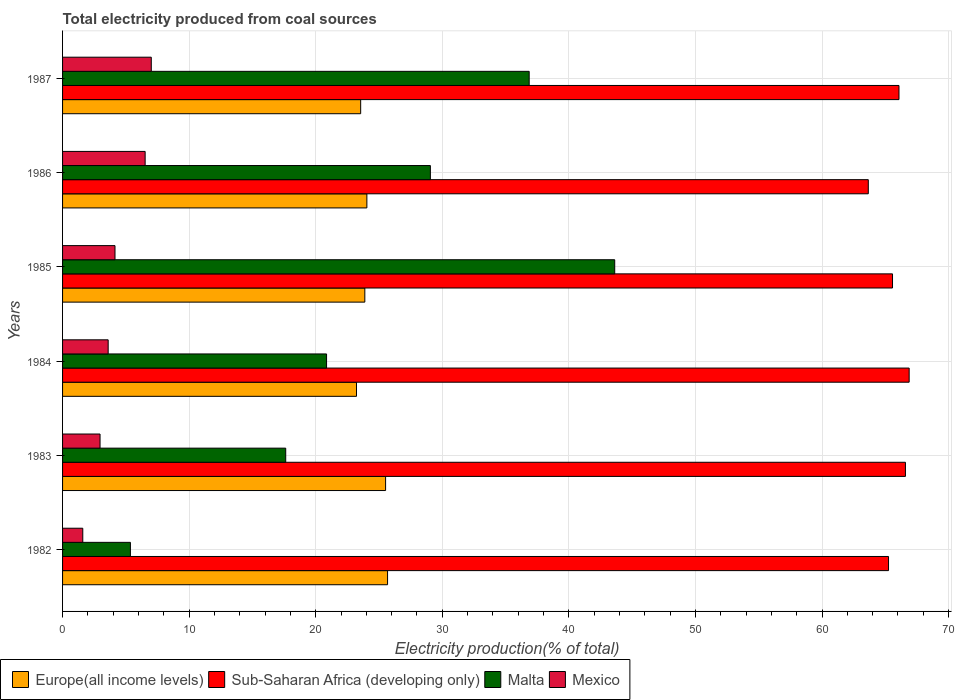How many different coloured bars are there?
Offer a terse response. 4. How many groups of bars are there?
Your response must be concise. 6. Are the number of bars per tick equal to the number of legend labels?
Make the answer very short. Yes. How many bars are there on the 2nd tick from the bottom?
Provide a succinct answer. 4. What is the label of the 4th group of bars from the top?
Make the answer very short. 1984. In how many cases, is the number of bars for a given year not equal to the number of legend labels?
Your response must be concise. 0. What is the total electricity produced in Malta in 1984?
Provide a short and direct response. 20.86. Across all years, what is the maximum total electricity produced in Sub-Saharan Africa (developing only)?
Keep it short and to the point. 66.88. Across all years, what is the minimum total electricity produced in Mexico?
Provide a short and direct response. 1.6. In which year was the total electricity produced in Sub-Saharan Africa (developing only) maximum?
Your answer should be compact. 1984. In which year was the total electricity produced in Mexico minimum?
Give a very brief answer. 1982. What is the total total electricity produced in Malta in the graph?
Your response must be concise. 153.39. What is the difference between the total electricity produced in Malta in 1984 and that in 1986?
Your answer should be very brief. -8.2. What is the difference between the total electricity produced in Mexico in 1985 and the total electricity produced in Europe(all income levels) in 1986?
Make the answer very short. -19.9. What is the average total electricity produced in Sub-Saharan Africa (developing only) per year?
Give a very brief answer. 65.67. In the year 1984, what is the difference between the total electricity produced in Sub-Saharan Africa (developing only) and total electricity produced in Europe(all income levels)?
Offer a very short reply. 43.66. In how many years, is the total electricity produced in Sub-Saharan Africa (developing only) greater than 56 %?
Offer a very short reply. 6. What is the ratio of the total electricity produced in Malta in 1982 to that in 1983?
Keep it short and to the point. 0.3. What is the difference between the highest and the second highest total electricity produced in Malta?
Keep it short and to the point. 6.76. What is the difference between the highest and the lowest total electricity produced in Europe(all income levels)?
Keep it short and to the point. 2.45. In how many years, is the total electricity produced in Europe(all income levels) greater than the average total electricity produced in Europe(all income levels) taken over all years?
Keep it short and to the point. 2. Is the sum of the total electricity produced in Malta in 1982 and 1986 greater than the maximum total electricity produced in Mexico across all years?
Your response must be concise. Yes. Is it the case that in every year, the sum of the total electricity produced in Malta and total electricity produced in Sub-Saharan Africa (developing only) is greater than the sum of total electricity produced in Europe(all income levels) and total electricity produced in Mexico?
Provide a succinct answer. Yes. What does the 2nd bar from the top in 1985 represents?
Give a very brief answer. Malta. What does the 1st bar from the bottom in 1984 represents?
Ensure brevity in your answer.  Europe(all income levels). Is it the case that in every year, the sum of the total electricity produced in Mexico and total electricity produced in Sub-Saharan Africa (developing only) is greater than the total electricity produced in Europe(all income levels)?
Provide a succinct answer. Yes. Where does the legend appear in the graph?
Your response must be concise. Bottom left. What is the title of the graph?
Offer a terse response. Total electricity produced from coal sources. What is the label or title of the X-axis?
Ensure brevity in your answer.  Electricity production(% of total). What is the label or title of the Y-axis?
Your response must be concise. Years. What is the Electricity production(% of total) in Europe(all income levels) in 1982?
Make the answer very short. 25.68. What is the Electricity production(% of total) of Sub-Saharan Africa (developing only) in 1982?
Offer a terse response. 65.25. What is the Electricity production(% of total) in Malta in 1982?
Offer a terse response. 5.36. What is the Electricity production(% of total) in Mexico in 1982?
Provide a short and direct response. 1.6. What is the Electricity production(% of total) of Europe(all income levels) in 1983?
Provide a succinct answer. 25.52. What is the Electricity production(% of total) of Sub-Saharan Africa (developing only) in 1983?
Your answer should be compact. 66.59. What is the Electricity production(% of total) of Malta in 1983?
Your answer should be very brief. 17.63. What is the Electricity production(% of total) of Mexico in 1983?
Provide a short and direct response. 2.96. What is the Electricity production(% of total) of Europe(all income levels) in 1984?
Ensure brevity in your answer.  23.22. What is the Electricity production(% of total) of Sub-Saharan Africa (developing only) in 1984?
Ensure brevity in your answer.  66.88. What is the Electricity production(% of total) of Malta in 1984?
Your answer should be compact. 20.86. What is the Electricity production(% of total) of Mexico in 1984?
Make the answer very short. 3.6. What is the Electricity production(% of total) of Europe(all income levels) in 1985?
Your response must be concise. 23.88. What is the Electricity production(% of total) in Sub-Saharan Africa (developing only) in 1985?
Your answer should be compact. 65.57. What is the Electricity production(% of total) in Malta in 1985?
Provide a short and direct response. 43.62. What is the Electricity production(% of total) of Mexico in 1985?
Provide a short and direct response. 4.14. What is the Electricity production(% of total) in Europe(all income levels) in 1986?
Make the answer very short. 24.04. What is the Electricity production(% of total) of Sub-Saharan Africa (developing only) in 1986?
Offer a very short reply. 63.66. What is the Electricity production(% of total) of Malta in 1986?
Make the answer very short. 29.06. What is the Electricity production(% of total) of Mexico in 1986?
Provide a succinct answer. 6.52. What is the Electricity production(% of total) of Europe(all income levels) in 1987?
Make the answer very short. 23.55. What is the Electricity production(% of total) in Sub-Saharan Africa (developing only) in 1987?
Your answer should be very brief. 66.08. What is the Electricity production(% of total) in Malta in 1987?
Provide a short and direct response. 36.86. What is the Electricity production(% of total) of Mexico in 1987?
Offer a terse response. 7.01. Across all years, what is the maximum Electricity production(% of total) in Europe(all income levels)?
Give a very brief answer. 25.68. Across all years, what is the maximum Electricity production(% of total) of Sub-Saharan Africa (developing only)?
Your answer should be compact. 66.88. Across all years, what is the maximum Electricity production(% of total) of Malta?
Your answer should be compact. 43.62. Across all years, what is the maximum Electricity production(% of total) of Mexico?
Provide a short and direct response. 7.01. Across all years, what is the minimum Electricity production(% of total) in Europe(all income levels)?
Offer a terse response. 23.22. Across all years, what is the minimum Electricity production(% of total) in Sub-Saharan Africa (developing only)?
Offer a very short reply. 63.66. Across all years, what is the minimum Electricity production(% of total) of Malta?
Your answer should be compact. 5.36. Across all years, what is the minimum Electricity production(% of total) in Mexico?
Your response must be concise. 1.6. What is the total Electricity production(% of total) of Europe(all income levels) in the graph?
Ensure brevity in your answer.  145.89. What is the total Electricity production(% of total) in Sub-Saharan Africa (developing only) in the graph?
Ensure brevity in your answer.  394.04. What is the total Electricity production(% of total) of Malta in the graph?
Your response must be concise. 153.39. What is the total Electricity production(% of total) in Mexico in the graph?
Make the answer very short. 25.83. What is the difference between the Electricity production(% of total) of Europe(all income levels) in 1982 and that in 1983?
Your answer should be compact. 0.16. What is the difference between the Electricity production(% of total) of Sub-Saharan Africa (developing only) in 1982 and that in 1983?
Keep it short and to the point. -1.34. What is the difference between the Electricity production(% of total) in Malta in 1982 and that in 1983?
Ensure brevity in your answer.  -12.27. What is the difference between the Electricity production(% of total) of Mexico in 1982 and that in 1983?
Keep it short and to the point. -1.36. What is the difference between the Electricity production(% of total) of Europe(all income levels) in 1982 and that in 1984?
Your answer should be very brief. 2.45. What is the difference between the Electricity production(% of total) in Sub-Saharan Africa (developing only) in 1982 and that in 1984?
Provide a succinct answer. -1.63. What is the difference between the Electricity production(% of total) in Malta in 1982 and that in 1984?
Your response must be concise. -15.5. What is the difference between the Electricity production(% of total) of Mexico in 1982 and that in 1984?
Make the answer very short. -2.01. What is the difference between the Electricity production(% of total) of Europe(all income levels) in 1982 and that in 1985?
Ensure brevity in your answer.  1.8. What is the difference between the Electricity production(% of total) in Sub-Saharan Africa (developing only) in 1982 and that in 1985?
Your answer should be compact. -0.31. What is the difference between the Electricity production(% of total) in Malta in 1982 and that in 1985?
Offer a terse response. -38.26. What is the difference between the Electricity production(% of total) in Mexico in 1982 and that in 1985?
Make the answer very short. -2.55. What is the difference between the Electricity production(% of total) in Europe(all income levels) in 1982 and that in 1986?
Offer a very short reply. 1.63. What is the difference between the Electricity production(% of total) in Sub-Saharan Africa (developing only) in 1982 and that in 1986?
Your answer should be very brief. 1.6. What is the difference between the Electricity production(% of total) in Malta in 1982 and that in 1986?
Give a very brief answer. -23.7. What is the difference between the Electricity production(% of total) in Mexico in 1982 and that in 1986?
Offer a terse response. -4.93. What is the difference between the Electricity production(% of total) in Europe(all income levels) in 1982 and that in 1987?
Your response must be concise. 2.12. What is the difference between the Electricity production(% of total) of Sub-Saharan Africa (developing only) in 1982 and that in 1987?
Your response must be concise. -0.83. What is the difference between the Electricity production(% of total) of Malta in 1982 and that in 1987?
Offer a very short reply. -31.5. What is the difference between the Electricity production(% of total) in Mexico in 1982 and that in 1987?
Provide a succinct answer. -5.41. What is the difference between the Electricity production(% of total) in Europe(all income levels) in 1983 and that in 1984?
Give a very brief answer. 2.3. What is the difference between the Electricity production(% of total) in Sub-Saharan Africa (developing only) in 1983 and that in 1984?
Provide a succinct answer. -0.29. What is the difference between the Electricity production(% of total) of Malta in 1983 and that in 1984?
Your answer should be very brief. -3.23. What is the difference between the Electricity production(% of total) of Mexico in 1983 and that in 1984?
Your answer should be compact. -0.64. What is the difference between the Electricity production(% of total) in Europe(all income levels) in 1983 and that in 1985?
Provide a short and direct response. 1.64. What is the difference between the Electricity production(% of total) in Sub-Saharan Africa (developing only) in 1983 and that in 1985?
Ensure brevity in your answer.  1.02. What is the difference between the Electricity production(% of total) in Malta in 1983 and that in 1985?
Give a very brief answer. -25.99. What is the difference between the Electricity production(% of total) in Mexico in 1983 and that in 1985?
Your answer should be very brief. -1.18. What is the difference between the Electricity production(% of total) of Europe(all income levels) in 1983 and that in 1986?
Offer a very short reply. 1.48. What is the difference between the Electricity production(% of total) of Sub-Saharan Africa (developing only) in 1983 and that in 1986?
Provide a short and direct response. 2.93. What is the difference between the Electricity production(% of total) of Malta in 1983 and that in 1986?
Give a very brief answer. -11.43. What is the difference between the Electricity production(% of total) of Mexico in 1983 and that in 1986?
Your response must be concise. -3.56. What is the difference between the Electricity production(% of total) of Europe(all income levels) in 1983 and that in 1987?
Your answer should be compact. 1.97. What is the difference between the Electricity production(% of total) in Sub-Saharan Africa (developing only) in 1983 and that in 1987?
Offer a terse response. 0.51. What is the difference between the Electricity production(% of total) of Malta in 1983 and that in 1987?
Ensure brevity in your answer.  -19.23. What is the difference between the Electricity production(% of total) in Mexico in 1983 and that in 1987?
Ensure brevity in your answer.  -4.05. What is the difference between the Electricity production(% of total) in Europe(all income levels) in 1984 and that in 1985?
Your answer should be very brief. -0.66. What is the difference between the Electricity production(% of total) in Sub-Saharan Africa (developing only) in 1984 and that in 1985?
Provide a succinct answer. 1.31. What is the difference between the Electricity production(% of total) of Malta in 1984 and that in 1985?
Your answer should be very brief. -22.77. What is the difference between the Electricity production(% of total) of Mexico in 1984 and that in 1985?
Make the answer very short. -0.54. What is the difference between the Electricity production(% of total) in Europe(all income levels) in 1984 and that in 1986?
Your answer should be very brief. -0.82. What is the difference between the Electricity production(% of total) in Sub-Saharan Africa (developing only) in 1984 and that in 1986?
Offer a terse response. 3.23. What is the difference between the Electricity production(% of total) in Malta in 1984 and that in 1986?
Provide a short and direct response. -8.2. What is the difference between the Electricity production(% of total) in Mexico in 1984 and that in 1986?
Your answer should be compact. -2.92. What is the difference between the Electricity production(% of total) of Europe(all income levels) in 1984 and that in 1987?
Provide a short and direct response. -0.33. What is the difference between the Electricity production(% of total) of Sub-Saharan Africa (developing only) in 1984 and that in 1987?
Give a very brief answer. 0.8. What is the difference between the Electricity production(% of total) in Malta in 1984 and that in 1987?
Ensure brevity in your answer.  -16.01. What is the difference between the Electricity production(% of total) of Mexico in 1984 and that in 1987?
Your answer should be very brief. -3.41. What is the difference between the Electricity production(% of total) of Europe(all income levels) in 1985 and that in 1986?
Provide a short and direct response. -0.16. What is the difference between the Electricity production(% of total) in Sub-Saharan Africa (developing only) in 1985 and that in 1986?
Keep it short and to the point. 1.91. What is the difference between the Electricity production(% of total) in Malta in 1985 and that in 1986?
Your answer should be compact. 14.56. What is the difference between the Electricity production(% of total) of Mexico in 1985 and that in 1986?
Keep it short and to the point. -2.38. What is the difference between the Electricity production(% of total) of Europe(all income levels) in 1985 and that in 1987?
Give a very brief answer. 0.33. What is the difference between the Electricity production(% of total) of Sub-Saharan Africa (developing only) in 1985 and that in 1987?
Keep it short and to the point. -0.51. What is the difference between the Electricity production(% of total) of Malta in 1985 and that in 1987?
Provide a short and direct response. 6.76. What is the difference between the Electricity production(% of total) of Mexico in 1985 and that in 1987?
Offer a terse response. -2.87. What is the difference between the Electricity production(% of total) of Europe(all income levels) in 1986 and that in 1987?
Provide a succinct answer. 0.49. What is the difference between the Electricity production(% of total) in Sub-Saharan Africa (developing only) in 1986 and that in 1987?
Provide a short and direct response. -2.42. What is the difference between the Electricity production(% of total) in Malta in 1986 and that in 1987?
Your answer should be very brief. -7.81. What is the difference between the Electricity production(% of total) of Mexico in 1986 and that in 1987?
Offer a very short reply. -0.48. What is the difference between the Electricity production(% of total) of Europe(all income levels) in 1982 and the Electricity production(% of total) of Sub-Saharan Africa (developing only) in 1983?
Your answer should be compact. -40.91. What is the difference between the Electricity production(% of total) of Europe(all income levels) in 1982 and the Electricity production(% of total) of Malta in 1983?
Make the answer very short. 8.05. What is the difference between the Electricity production(% of total) in Europe(all income levels) in 1982 and the Electricity production(% of total) in Mexico in 1983?
Your response must be concise. 22.72. What is the difference between the Electricity production(% of total) of Sub-Saharan Africa (developing only) in 1982 and the Electricity production(% of total) of Malta in 1983?
Give a very brief answer. 47.63. What is the difference between the Electricity production(% of total) in Sub-Saharan Africa (developing only) in 1982 and the Electricity production(% of total) in Mexico in 1983?
Provide a succinct answer. 62.29. What is the difference between the Electricity production(% of total) in Malta in 1982 and the Electricity production(% of total) in Mexico in 1983?
Make the answer very short. 2.4. What is the difference between the Electricity production(% of total) of Europe(all income levels) in 1982 and the Electricity production(% of total) of Sub-Saharan Africa (developing only) in 1984?
Offer a very short reply. -41.21. What is the difference between the Electricity production(% of total) of Europe(all income levels) in 1982 and the Electricity production(% of total) of Malta in 1984?
Offer a terse response. 4.82. What is the difference between the Electricity production(% of total) of Europe(all income levels) in 1982 and the Electricity production(% of total) of Mexico in 1984?
Provide a succinct answer. 22.07. What is the difference between the Electricity production(% of total) of Sub-Saharan Africa (developing only) in 1982 and the Electricity production(% of total) of Malta in 1984?
Keep it short and to the point. 44.4. What is the difference between the Electricity production(% of total) in Sub-Saharan Africa (developing only) in 1982 and the Electricity production(% of total) in Mexico in 1984?
Keep it short and to the point. 61.65. What is the difference between the Electricity production(% of total) of Malta in 1982 and the Electricity production(% of total) of Mexico in 1984?
Provide a short and direct response. 1.76. What is the difference between the Electricity production(% of total) in Europe(all income levels) in 1982 and the Electricity production(% of total) in Sub-Saharan Africa (developing only) in 1985?
Make the answer very short. -39.89. What is the difference between the Electricity production(% of total) in Europe(all income levels) in 1982 and the Electricity production(% of total) in Malta in 1985?
Your answer should be very brief. -17.95. What is the difference between the Electricity production(% of total) in Europe(all income levels) in 1982 and the Electricity production(% of total) in Mexico in 1985?
Ensure brevity in your answer.  21.53. What is the difference between the Electricity production(% of total) in Sub-Saharan Africa (developing only) in 1982 and the Electricity production(% of total) in Malta in 1985?
Give a very brief answer. 21.63. What is the difference between the Electricity production(% of total) in Sub-Saharan Africa (developing only) in 1982 and the Electricity production(% of total) in Mexico in 1985?
Offer a terse response. 61.11. What is the difference between the Electricity production(% of total) in Malta in 1982 and the Electricity production(% of total) in Mexico in 1985?
Offer a terse response. 1.22. What is the difference between the Electricity production(% of total) of Europe(all income levels) in 1982 and the Electricity production(% of total) of Sub-Saharan Africa (developing only) in 1986?
Provide a short and direct response. -37.98. What is the difference between the Electricity production(% of total) of Europe(all income levels) in 1982 and the Electricity production(% of total) of Malta in 1986?
Offer a very short reply. -3.38. What is the difference between the Electricity production(% of total) in Europe(all income levels) in 1982 and the Electricity production(% of total) in Mexico in 1986?
Keep it short and to the point. 19.15. What is the difference between the Electricity production(% of total) in Sub-Saharan Africa (developing only) in 1982 and the Electricity production(% of total) in Malta in 1986?
Your answer should be very brief. 36.2. What is the difference between the Electricity production(% of total) in Sub-Saharan Africa (developing only) in 1982 and the Electricity production(% of total) in Mexico in 1986?
Your answer should be compact. 58.73. What is the difference between the Electricity production(% of total) in Malta in 1982 and the Electricity production(% of total) in Mexico in 1986?
Provide a short and direct response. -1.16. What is the difference between the Electricity production(% of total) of Europe(all income levels) in 1982 and the Electricity production(% of total) of Sub-Saharan Africa (developing only) in 1987?
Make the answer very short. -40.4. What is the difference between the Electricity production(% of total) of Europe(all income levels) in 1982 and the Electricity production(% of total) of Malta in 1987?
Give a very brief answer. -11.19. What is the difference between the Electricity production(% of total) of Europe(all income levels) in 1982 and the Electricity production(% of total) of Mexico in 1987?
Your answer should be compact. 18.67. What is the difference between the Electricity production(% of total) of Sub-Saharan Africa (developing only) in 1982 and the Electricity production(% of total) of Malta in 1987?
Offer a very short reply. 28.39. What is the difference between the Electricity production(% of total) of Sub-Saharan Africa (developing only) in 1982 and the Electricity production(% of total) of Mexico in 1987?
Your response must be concise. 58.25. What is the difference between the Electricity production(% of total) of Malta in 1982 and the Electricity production(% of total) of Mexico in 1987?
Your answer should be compact. -1.65. What is the difference between the Electricity production(% of total) of Europe(all income levels) in 1983 and the Electricity production(% of total) of Sub-Saharan Africa (developing only) in 1984?
Your answer should be compact. -41.36. What is the difference between the Electricity production(% of total) in Europe(all income levels) in 1983 and the Electricity production(% of total) in Malta in 1984?
Offer a very short reply. 4.66. What is the difference between the Electricity production(% of total) of Europe(all income levels) in 1983 and the Electricity production(% of total) of Mexico in 1984?
Your response must be concise. 21.92. What is the difference between the Electricity production(% of total) in Sub-Saharan Africa (developing only) in 1983 and the Electricity production(% of total) in Malta in 1984?
Give a very brief answer. 45.73. What is the difference between the Electricity production(% of total) in Sub-Saharan Africa (developing only) in 1983 and the Electricity production(% of total) in Mexico in 1984?
Give a very brief answer. 62.99. What is the difference between the Electricity production(% of total) of Malta in 1983 and the Electricity production(% of total) of Mexico in 1984?
Ensure brevity in your answer.  14.03. What is the difference between the Electricity production(% of total) in Europe(all income levels) in 1983 and the Electricity production(% of total) in Sub-Saharan Africa (developing only) in 1985?
Provide a short and direct response. -40.05. What is the difference between the Electricity production(% of total) of Europe(all income levels) in 1983 and the Electricity production(% of total) of Malta in 1985?
Keep it short and to the point. -18.1. What is the difference between the Electricity production(% of total) of Europe(all income levels) in 1983 and the Electricity production(% of total) of Mexico in 1985?
Your answer should be very brief. 21.38. What is the difference between the Electricity production(% of total) of Sub-Saharan Africa (developing only) in 1983 and the Electricity production(% of total) of Malta in 1985?
Give a very brief answer. 22.97. What is the difference between the Electricity production(% of total) in Sub-Saharan Africa (developing only) in 1983 and the Electricity production(% of total) in Mexico in 1985?
Keep it short and to the point. 62.45. What is the difference between the Electricity production(% of total) of Malta in 1983 and the Electricity production(% of total) of Mexico in 1985?
Your answer should be very brief. 13.49. What is the difference between the Electricity production(% of total) in Europe(all income levels) in 1983 and the Electricity production(% of total) in Sub-Saharan Africa (developing only) in 1986?
Your response must be concise. -38.14. What is the difference between the Electricity production(% of total) in Europe(all income levels) in 1983 and the Electricity production(% of total) in Malta in 1986?
Offer a very short reply. -3.54. What is the difference between the Electricity production(% of total) in Europe(all income levels) in 1983 and the Electricity production(% of total) in Mexico in 1986?
Keep it short and to the point. 19. What is the difference between the Electricity production(% of total) of Sub-Saharan Africa (developing only) in 1983 and the Electricity production(% of total) of Malta in 1986?
Offer a terse response. 37.53. What is the difference between the Electricity production(% of total) in Sub-Saharan Africa (developing only) in 1983 and the Electricity production(% of total) in Mexico in 1986?
Offer a very short reply. 60.07. What is the difference between the Electricity production(% of total) in Malta in 1983 and the Electricity production(% of total) in Mexico in 1986?
Your answer should be very brief. 11.11. What is the difference between the Electricity production(% of total) of Europe(all income levels) in 1983 and the Electricity production(% of total) of Sub-Saharan Africa (developing only) in 1987?
Offer a very short reply. -40.56. What is the difference between the Electricity production(% of total) of Europe(all income levels) in 1983 and the Electricity production(% of total) of Malta in 1987?
Give a very brief answer. -11.34. What is the difference between the Electricity production(% of total) of Europe(all income levels) in 1983 and the Electricity production(% of total) of Mexico in 1987?
Provide a succinct answer. 18.51. What is the difference between the Electricity production(% of total) in Sub-Saharan Africa (developing only) in 1983 and the Electricity production(% of total) in Malta in 1987?
Provide a short and direct response. 29.73. What is the difference between the Electricity production(% of total) in Sub-Saharan Africa (developing only) in 1983 and the Electricity production(% of total) in Mexico in 1987?
Provide a short and direct response. 59.58. What is the difference between the Electricity production(% of total) of Malta in 1983 and the Electricity production(% of total) of Mexico in 1987?
Make the answer very short. 10.62. What is the difference between the Electricity production(% of total) of Europe(all income levels) in 1984 and the Electricity production(% of total) of Sub-Saharan Africa (developing only) in 1985?
Give a very brief answer. -42.35. What is the difference between the Electricity production(% of total) in Europe(all income levels) in 1984 and the Electricity production(% of total) in Malta in 1985?
Offer a terse response. -20.4. What is the difference between the Electricity production(% of total) of Europe(all income levels) in 1984 and the Electricity production(% of total) of Mexico in 1985?
Offer a very short reply. 19.08. What is the difference between the Electricity production(% of total) of Sub-Saharan Africa (developing only) in 1984 and the Electricity production(% of total) of Malta in 1985?
Make the answer very short. 23.26. What is the difference between the Electricity production(% of total) of Sub-Saharan Africa (developing only) in 1984 and the Electricity production(% of total) of Mexico in 1985?
Give a very brief answer. 62.74. What is the difference between the Electricity production(% of total) of Malta in 1984 and the Electricity production(% of total) of Mexico in 1985?
Your response must be concise. 16.71. What is the difference between the Electricity production(% of total) of Europe(all income levels) in 1984 and the Electricity production(% of total) of Sub-Saharan Africa (developing only) in 1986?
Ensure brevity in your answer.  -40.43. What is the difference between the Electricity production(% of total) of Europe(all income levels) in 1984 and the Electricity production(% of total) of Malta in 1986?
Provide a short and direct response. -5.84. What is the difference between the Electricity production(% of total) of Europe(all income levels) in 1984 and the Electricity production(% of total) of Mexico in 1986?
Give a very brief answer. 16.7. What is the difference between the Electricity production(% of total) of Sub-Saharan Africa (developing only) in 1984 and the Electricity production(% of total) of Malta in 1986?
Your response must be concise. 37.83. What is the difference between the Electricity production(% of total) of Sub-Saharan Africa (developing only) in 1984 and the Electricity production(% of total) of Mexico in 1986?
Keep it short and to the point. 60.36. What is the difference between the Electricity production(% of total) in Malta in 1984 and the Electricity production(% of total) in Mexico in 1986?
Offer a very short reply. 14.33. What is the difference between the Electricity production(% of total) in Europe(all income levels) in 1984 and the Electricity production(% of total) in Sub-Saharan Africa (developing only) in 1987?
Keep it short and to the point. -42.86. What is the difference between the Electricity production(% of total) in Europe(all income levels) in 1984 and the Electricity production(% of total) in Malta in 1987?
Keep it short and to the point. -13.64. What is the difference between the Electricity production(% of total) in Europe(all income levels) in 1984 and the Electricity production(% of total) in Mexico in 1987?
Provide a succinct answer. 16.21. What is the difference between the Electricity production(% of total) in Sub-Saharan Africa (developing only) in 1984 and the Electricity production(% of total) in Malta in 1987?
Your answer should be compact. 30.02. What is the difference between the Electricity production(% of total) in Sub-Saharan Africa (developing only) in 1984 and the Electricity production(% of total) in Mexico in 1987?
Provide a succinct answer. 59.88. What is the difference between the Electricity production(% of total) in Malta in 1984 and the Electricity production(% of total) in Mexico in 1987?
Keep it short and to the point. 13.85. What is the difference between the Electricity production(% of total) in Europe(all income levels) in 1985 and the Electricity production(% of total) in Sub-Saharan Africa (developing only) in 1986?
Offer a terse response. -39.78. What is the difference between the Electricity production(% of total) of Europe(all income levels) in 1985 and the Electricity production(% of total) of Malta in 1986?
Make the answer very short. -5.18. What is the difference between the Electricity production(% of total) in Europe(all income levels) in 1985 and the Electricity production(% of total) in Mexico in 1986?
Offer a terse response. 17.36. What is the difference between the Electricity production(% of total) of Sub-Saharan Africa (developing only) in 1985 and the Electricity production(% of total) of Malta in 1986?
Provide a short and direct response. 36.51. What is the difference between the Electricity production(% of total) of Sub-Saharan Africa (developing only) in 1985 and the Electricity production(% of total) of Mexico in 1986?
Ensure brevity in your answer.  59.05. What is the difference between the Electricity production(% of total) of Malta in 1985 and the Electricity production(% of total) of Mexico in 1986?
Ensure brevity in your answer.  37.1. What is the difference between the Electricity production(% of total) in Europe(all income levels) in 1985 and the Electricity production(% of total) in Sub-Saharan Africa (developing only) in 1987?
Make the answer very short. -42.2. What is the difference between the Electricity production(% of total) of Europe(all income levels) in 1985 and the Electricity production(% of total) of Malta in 1987?
Your answer should be very brief. -12.98. What is the difference between the Electricity production(% of total) in Europe(all income levels) in 1985 and the Electricity production(% of total) in Mexico in 1987?
Keep it short and to the point. 16.87. What is the difference between the Electricity production(% of total) of Sub-Saharan Africa (developing only) in 1985 and the Electricity production(% of total) of Malta in 1987?
Your answer should be compact. 28.7. What is the difference between the Electricity production(% of total) in Sub-Saharan Africa (developing only) in 1985 and the Electricity production(% of total) in Mexico in 1987?
Your answer should be very brief. 58.56. What is the difference between the Electricity production(% of total) in Malta in 1985 and the Electricity production(% of total) in Mexico in 1987?
Keep it short and to the point. 36.61. What is the difference between the Electricity production(% of total) of Europe(all income levels) in 1986 and the Electricity production(% of total) of Sub-Saharan Africa (developing only) in 1987?
Ensure brevity in your answer.  -42.04. What is the difference between the Electricity production(% of total) in Europe(all income levels) in 1986 and the Electricity production(% of total) in Malta in 1987?
Your answer should be very brief. -12.82. What is the difference between the Electricity production(% of total) of Europe(all income levels) in 1986 and the Electricity production(% of total) of Mexico in 1987?
Keep it short and to the point. 17.03. What is the difference between the Electricity production(% of total) in Sub-Saharan Africa (developing only) in 1986 and the Electricity production(% of total) in Malta in 1987?
Provide a succinct answer. 26.79. What is the difference between the Electricity production(% of total) in Sub-Saharan Africa (developing only) in 1986 and the Electricity production(% of total) in Mexico in 1987?
Your answer should be compact. 56.65. What is the difference between the Electricity production(% of total) in Malta in 1986 and the Electricity production(% of total) in Mexico in 1987?
Make the answer very short. 22.05. What is the average Electricity production(% of total) of Europe(all income levels) per year?
Offer a terse response. 24.32. What is the average Electricity production(% of total) in Sub-Saharan Africa (developing only) per year?
Offer a terse response. 65.67. What is the average Electricity production(% of total) in Malta per year?
Keep it short and to the point. 25.57. What is the average Electricity production(% of total) of Mexico per year?
Offer a very short reply. 4.31. In the year 1982, what is the difference between the Electricity production(% of total) of Europe(all income levels) and Electricity production(% of total) of Sub-Saharan Africa (developing only)?
Ensure brevity in your answer.  -39.58. In the year 1982, what is the difference between the Electricity production(% of total) of Europe(all income levels) and Electricity production(% of total) of Malta?
Ensure brevity in your answer.  20.32. In the year 1982, what is the difference between the Electricity production(% of total) of Europe(all income levels) and Electricity production(% of total) of Mexico?
Your answer should be compact. 24.08. In the year 1982, what is the difference between the Electricity production(% of total) of Sub-Saharan Africa (developing only) and Electricity production(% of total) of Malta?
Keep it short and to the point. 59.89. In the year 1982, what is the difference between the Electricity production(% of total) in Sub-Saharan Africa (developing only) and Electricity production(% of total) in Mexico?
Your response must be concise. 63.66. In the year 1982, what is the difference between the Electricity production(% of total) in Malta and Electricity production(% of total) in Mexico?
Provide a short and direct response. 3.76. In the year 1983, what is the difference between the Electricity production(% of total) of Europe(all income levels) and Electricity production(% of total) of Sub-Saharan Africa (developing only)?
Offer a terse response. -41.07. In the year 1983, what is the difference between the Electricity production(% of total) of Europe(all income levels) and Electricity production(% of total) of Malta?
Offer a very short reply. 7.89. In the year 1983, what is the difference between the Electricity production(% of total) of Europe(all income levels) and Electricity production(% of total) of Mexico?
Your response must be concise. 22.56. In the year 1983, what is the difference between the Electricity production(% of total) in Sub-Saharan Africa (developing only) and Electricity production(% of total) in Malta?
Ensure brevity in your answer.  48.96. In the year 1983, what is the difference between the Electricity production(% of total) in Sub-Saharan Africa (developing only) and Electricity production(% of total) in Mexico?
Provide a short and direct response. 63.63. In the year 1983, what is the difference between the Electricity production(% of total) in Malta and Electricity production(% of total) in Mexico?
Make the answer very short. 14.67. In the year 1984, what is the difference between the Electricity production(% of total) in Europe(all income levels) and Electricity production(% of total) in Sub-Saharan Africa (developing only)?
Keep it short and to the point. -43.66. In the year 1984, what is the difference between the Electricity production(% of total) in Europe(all income levels) and Electricity production(% of total) in Malta?
Provide a succinct answer. 2.37. In the year 1984, what is the difference between the Electricity production(% of total) in Europe(all income levels) and Electricity production(% of total) in Mexico?
Your answer should be very brief. 19.62. In the year 1984, what is the difference between the Electricity production(% of total) in Sub-Saharan Africa (developing only) and Electricity production(% of total) in Malta?
Ensure brevity in your answer.  46.03. In the year 1984, what is the difference between the Electricity production(% of total) of Sub-Saharan Africa (developing only) and Electricity production(% of total) of Mexico?
Offer a very short reply. 63.28. In the year 1984, what is the difference between the Electricity production(% of total) of Malta and Electricity production(% of total) of Mexico?
Your response must be concise. 17.25. In the year 1985, what is the difference between the Electricity production(% of total) of Europe(all income levels) and Electricity production(% of total) of Sub-Saharan Africa (developing only)?
Your answer should be very brief. -41.69. In the year 1985, what is the difference between the Electricity production(% of total) of Europe(all income levels) and Electricity production(% of total) of Malta?
Provide a short and direct response. -19.74. In the year 1985, what is the difference between the Electricity production(% of total) of Europe(all income levels) and Electricity production(% of total) of Mexico?
Provide a short and direct response. 19.74. In the year 1985, what is the difference between the Electricity production(% of total) in Sub-Saharan Africa (developing only) and Electricity production(% of total) in Malta?
Keep it short and to the point. 21.95. In the year 1985, what is the difference between the Electricity production(% of total) in Sub-Saharan Africa (developing only) and Electricity production(% of total) in Mexico?
Your answer should be very brief. 61.43. In the year 1985, what is the difference between the Electricity production(% of total) of Malta and Electricity production(% of total) of Mexico?
Offer a very short reply. 39.48. In the year 1986, what is the difference between the Electricity production(% of total) in Europe(all income levels) and Electricity production(% of total) in Sub-Saharan Africa (developing only)?
Offer a terse response. -39.61. In the year 1986, what is the difference between the Electricity production(% of total) in Europe(all income levels) and Electricity production(% of total) in Malta?
Provide a short and direct response. -5.02. In the year 1986, what is the difference between the Electricity production(% of total) of Europe(all income levels) and Electricity production(% of total) of Mexico?
Your response must be concise. 17.52. In the year 1986, what is the difference between the Electricity production(% of total) in Sub-Saharan Africa (developing only) and Electricity production(% of total) in Malta?
Give a very brief answer. 34.6. In the year 1986, what is the difference between the Electricity production(% of total) in Sub-Saharan Africa (developing only) and Electricity production(% of total) in Mexico?
Your answer should be very brief. 57.13. In the year 1986, what is the difference between the Electricity production(% of total) in Malta and Electricity production(% of total) in Mexico?
Provide a succinct answer. 22.53. In the year 1987, what is the difference between the Electricity production(% of total) in Europe(all income levels) and Electricity production(% of total) in Sub-Saharan Africa (developing only)?
Offer a terse response. -42.53. In the year 1987, what is the difference between the Electricity production(% of total) in Europe(all income levels) and Electricity production(% of total) in Malta?
Offer a very short reply. -13.31. In the year 1987, what is the difference between the Electricity production(% of total) of Europe(all income levels) and Electricity production(% of total) of Mexico?
Keep it short and to the point. 16.54. In the year 1987, what is the difference between the Electricity production(% of total) of Sub-Saharan Africa (developing only) and Electricity production(% of total) of Malta?
Ensure brevity in your answer.  29.22. In the year 1987, what is the difference between the Electricity production(% of total) of Sub-Saharan Africa (developing only) and Electricity production(% of total) of Mexico?
Offer a very short reply. 59.07. In the year 1987, what is the difference between the Electricity production(% of total) in Malta and Electricity production(% of total) in Mexico?
Ensure brevity in your answer.  29.86. What is the ratio of the Electricity production(% of total) of Europe(all income levels) in 1982 to that in 1983?
Give a very brief answer. 1.01. What is the ratio of the Electricity production(% of total) of Sub-Saharan Africa (developing only) in 1982 to that in 1983?
Make the answer very short. 0.98. What is the ratio of the Electricity production(% of total) in Malta in 1982 to that in 1983?
Your answer should be compact. 0.3. What is the ratio of the Electricity production(% of total) of Mexico in 1982 to that in 1983?
Your answer should be very brief. 0.54. What is the ratio of the Electricity production(% of total) in Europe(all income levels) in 1982 to that in 1984?
Make the answer very short. 1.11. What is the ratio of the Electricity production(% of total) in Sub-Saharan Africa (developing only) in 1982 to that in 1984?
Make the answer very short. 0.98. What is the ratio of the Electricity production(% of total) of Malta in 1982 to that in 1984?
Give a very brief answer. 0.26. What is the ratio of the Electricity production(% of total) of Mexico in 1982 to that in 1984?
Make the answer very short. 0.44. What is the ratio of the Electricity production(% of total) in Europe(all income levels) in 1982 to that in 1985?
Provide a short and direct response. 1.08. What is the ratio of the Electricity production(% of total) in Sub-Saharan Africa (developing only) in 1982 to that in 1985?
Give a very brief answer. 1. What is the ratio of the Electricity production(% of total) of Malta in 1982 to that in 1985?
Ensure brevity in your answer.  0.12. What is the ratio of the Electricity production(% of total) of Mexico in 1982 to that in 1985?
Your response must be concise. 0.39. What is the ratio of the Electricity production(% of total) in Europe(all income levels) in 1982 to that in 1986?
Keep it short and to the point. 1.07. What is the ratio of the Electricity production(% of total) in Sub-Saharan Africa (developing only) in 1982 to that in 1986?
Provide a short and direct response. 1.03. What is the ratio of the Electricity production(% of total) in Malta in 1982 to that in 1986?
Make the answer very short. 0.18. What is the ratio of the Electricity production(% of total) in Mexico in 1982 to that in 1986?
Give a very brief answer. 0.24. What is the ratio of the Electricity production(% of total) of Europe(all income levels) in 1982 to that in 1987?
Give a very brief answer. 1.09. What is the ratio of the Electricity production(% of total) in Sub-Saharan Africa (developing only) in 1982 to that in 1987?
Make the answer very short. 0.99. What is the ratio of the Electricity production(% of total) in Malta in 1982 to that in 1987?
Your response must be concise. 0.15. What is the ratio of the Electricity production(% of total) in Mexico in 1982 to that in 1987?
Your answer should be compact. 0.23. What is the ratio of the Electricity production(% of total) in Europe(all income levels) in 1983 to that in 1984?
Your answer should be very brief. 1.1. What is the ratio of the Electricity production(% of total) of Sub-Saharan Africa (developing only) in 1983 to that in 1984?
Ensure brevity in your answer.  1. What is the ratio of the Electricity production(% of total) of Malta in 1983 to that in 1984?
Offer a terse response. 0.85. What is the ratio of the Electricity production(% of total) in Mexico in 1983 to that in 1984?
Keep it short and to the point. 0.82. What is the ratio of the Electricity production(% of total) in Europe(all income levels) in 1983 to that in 1985?
Your response must be concise. 1.07. What is the ratio of the Electricity production(% of total) of Sub-Saharan Africa (developing only) in 1983 to that in 1985?
Your answer should be compact. 1.02. What is the ratio of the Electricity production(% of total) of Malta in 1983 to that in 1985?
Your response must be concise. 0.4. What is the ratio of the Electricity production(% of total) of Mexico in 1983 to that in 1985?
Provide a short and direct response. 0.71. What is the ratio of the Electricity production(% of total) of Europe(all income levels) in 1983 to that in 1986?
Your answer should be very brief. 1.06. What is the ratio of the Electricity production(% of total) of Sub-Saharan Africa (developing only) in 1983 to that in 1986?
Make the answer very short. 1.05. What is the ratio of the Electricity production(% of total) in Malta in 1983 to that in 1986?
Provide a succinct answer. 0.61. What is the ratio of the Electricity production(% of total) of Mexico in 1983 to that in 1986?
Give a very brief answer. 0.45. What is the ratio of the Electricity production(% of total) of Europe(all income levels) in 1983 to that in 1987?
Give a very brief answer. 1.08. What is the ratio of the Electricity production(% of total) of Sub-Saharan Africa (developing only) in 1983 to that in 1987?
Keep it short and to the point. 1.01. What is the ratio of the Electricity production(% of total) of Malta in 1983 to that in 1987?
Make the answer very short. 0.48. What is the ratio of the Electricity production(% of total) of Mexico in 1983 to that in 1987?
Make the answer very short. 0.42. What is the ratio of the Electricity production(% of total) of Europe(all income levels) in 1984 to that in 1985?
Keep it short and to the point. 0.97. What is the ratio of the Electricity production(% of total) of Sub-Saharan Africa (developing only) in 1984 to that in 1985?
Make the answer very short. 1.02. What is the ratio of the Electricity production(% of total) of Malta in 1984 to that in 1985?
Offer a terse response. 0.48. What is the ratio of the Electricity production(% of total) in Mexico in 1984 to that in 1985?
Ensure brevity in your answer.  0.87. What is the ratio of the Electricity production(% of total) in Europe(all income levels) in 1984 to that in 1986?
Keep it short and to the point. 0.97. What is the ratio of the Electricity production(% of total) of Sub-Saharan Africa (developing only) in 1984 to that in 1986?
Provide a succinct answer. 1.05. What is the ratio of the Electricity production(% of total) in Malta in 1984 to that in 1986?
Provide a succinct answer. 0.72. What is the ratio of the Electricity production(% of total) in Mexico in 1984 to that in 1986?
Ensure brevity in your answer.  0.55. What is the ratio of the Electricity production(% of total) of Sub-Saharan Africa (developing only) in 1984 to that in 1987?
Give a very brief answer. 1.01. What is the ratio of the Electricity production(% of total) of Malta in 1984 to that in 1987?
Your response must be concise. 0.57. What is the ratio of the Electricity production(% of total) in Mexico in 1984 to that in 1987?
Provide a short and direct response. 0.51. What is the ratio of the Electricity production(% of total) in Europe(all income levels) in 1985 to that in 1986?
Your answer should be compact. 0.99. What is the ratio of the Electricity production(% of total) in Sub-Saharan Africa (developing only) in 1985 to that in 1986?
Keep it short and to the point. 1.03. What is the ratio of the Electricity production(% of total) in Malta in 1985 to that in 1986?
Offer a very short reply. 1.5. What is the ratio of the Electricity production(% of total) of Mexico in 1985 to that in 1986?
Offer a very short reply. 0.64. What is the ratio of the Electricity production(% of total) in Europe(all income levels) in 1985 to that in 1987?
Your response must be concise. 1.01. What is the ratio of the Electricity production(% of total) in Sub-Saharan Africa (developing only) in 1985 to that in 1987?
Offer a terse response. 0.99. What is the ratio of the Electricity production(% of total) in Malta in 1985 to that in 1987?
Offer a terse response. 1.18. What is the ratio of the Electricity production(% of total) in Mexico in 1985 to that in 1987?
Ensure brevity in your answer.  0.59. What is the ratio of the Electricity production(% of total) of Europe(all income levels) in 1986 to that in 1987?
Provide a short and direct response. 1.02. What is the ratio of the Electricity production(% of total) in Sub-Saharan Africa (developing only) in 1986 to that in 1987?
Your response must be concise. 0.96. What is the ratio of the Electricity production(% of total) in Malta in 1986 to that in 1987?
Ensure brevity in your answer.  0.79. What is the ratio of the Electricity production(% of total) in Mexico in 1986 to that in 1987?
Offer a terse response. 0.93. What is the difference between the highest and the second highest Electricity production(% of total) of Europe(all income levels)?
Provide a short and direct response. 0.16. What is the difference between the highest and the second highest Electricity production(% of total) of Sub-Saharan Africa (developing only)?
Make the answer very short. 0.29. What is the difference between the highest and the second highest Electricity production(% of total) of Malta?
Your response must be concise. 6.76. What is the difference between the highest and the second highest Electricity production(% of total) in Mexico?
Offer a very short reply. 0.48. What is the difference between the highest and the lowest Electricity production(% of total) in Europe(all income levels)?
Your answer should be compact. 2.45. What is the difference between the highest and the lowest Electricity production(% of total) of Sub-Saharan Africa (developing only)?
Provide a short and direct response. 3.23. What is the difference between the highest and the lowest Electricity production(% of total) of Malta?
Your response must be concise. 38.26. What is the difference between the highest and the lowest Electricity production(% of total) of Mexico?
Your answer should be very brief. 5.41. 